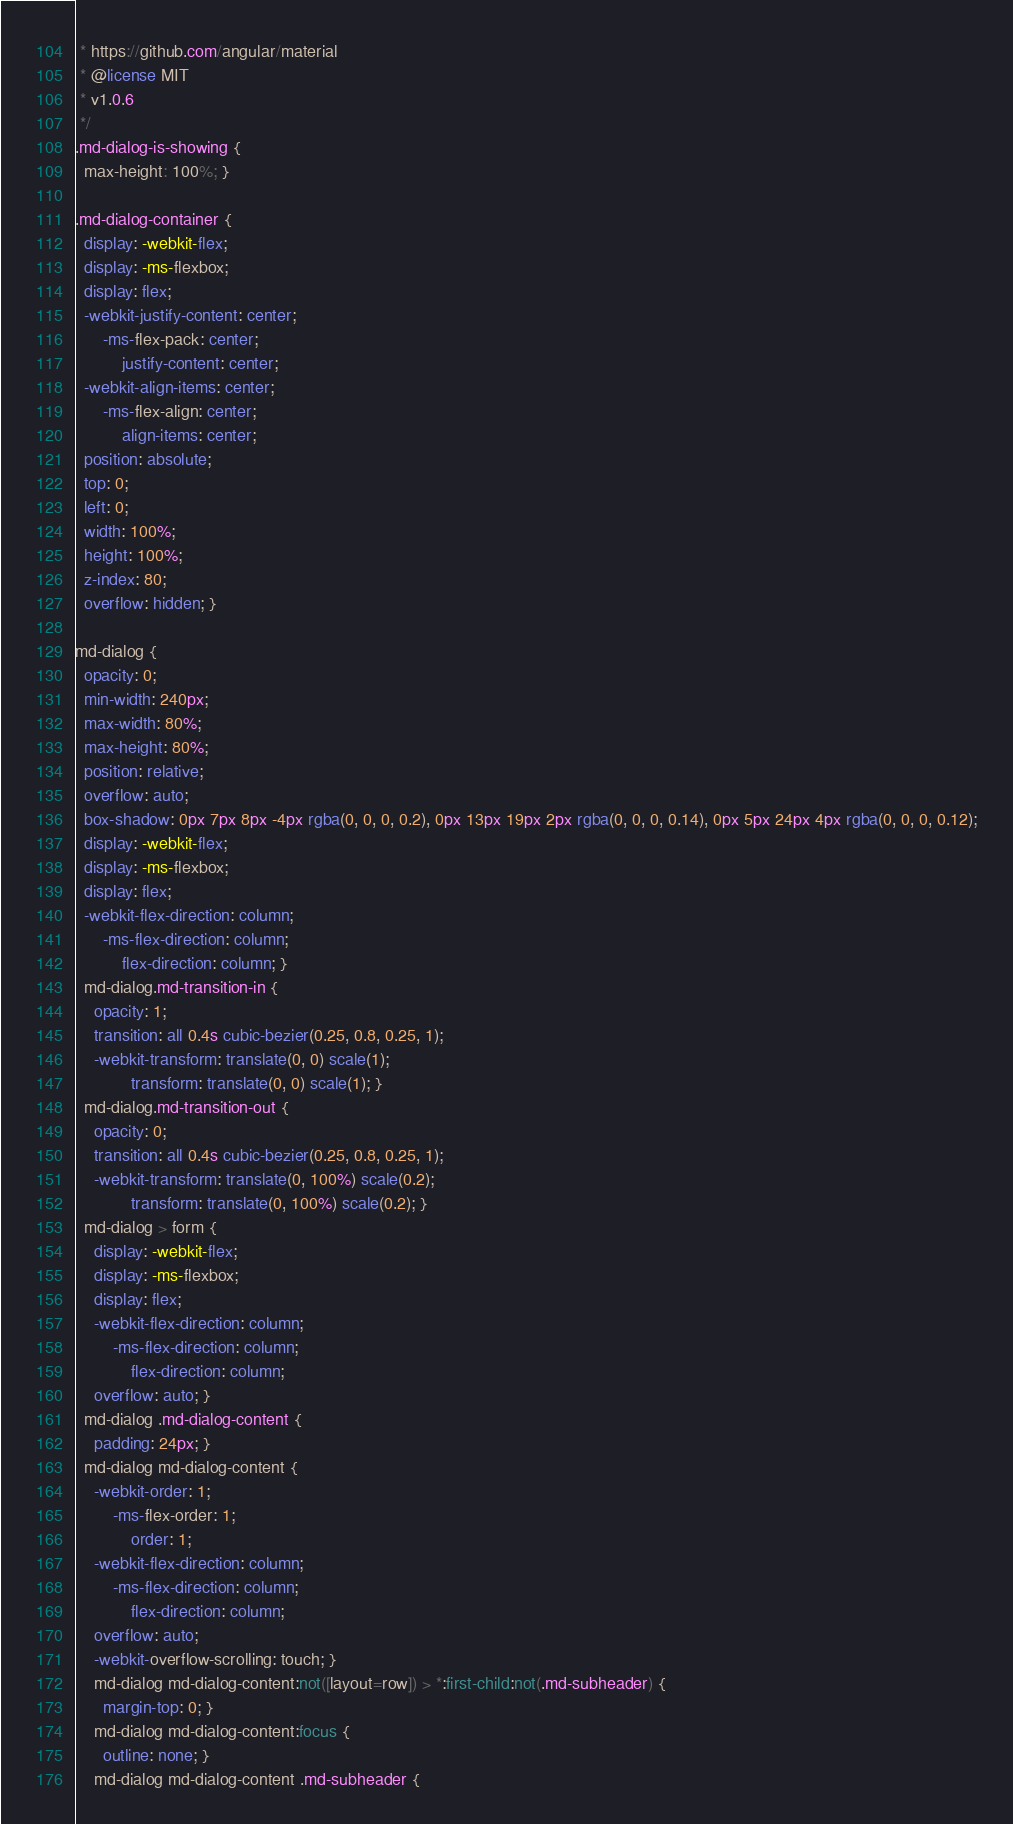Convert code to text. <code><loc_0><loc_0><loc_500><loc_500><_CSS_> * https://github.com/angular/material
 * @license MIT
 * v1.0.6
 */
.md-dialog-is-showing {
  max-height: 100%; }

.md-dialog-container {
  display: -webkit-flex;
  display: -ms-flexbox;
  display: flex;
  -webkit-justify-content: center;
      -ms-flex-pack: center;
          justify-content: center;
  -webkit-align-items: center;
      -ms-flex-align: center;
          align-items: center;
  position: absolute;
  top: 0;
  left: 0;
  width: 100%;
  height: 100%;
  z-index: 80;
  overflow: hidden; }

md-dialog {
  opacity: 0;
  min-width: 240px;
  max-width: 80%;
  max-height: 80%;
  position: relative;
  overflow: auto;
  box-shadow: 0px 7px 8px -4px rgba(0, 0, 0, 0.2), 0px 13px 19px 2px rgba(0, 0, 0, 0.14), 0px 5px 24px 4px rgba(0, 0, 0, 0.12);
  display: -webkit-flex;
  display: -ms-flexbox;
  display: flex;
  -webkit-flex-direction: column;
      -ms-flex-direction: column;
          flex-direction: column; }
  md-dialog.md-transition-in {
    opacity: 1;
    transition: all 0.4s cubic-bezier(0.25, 0.8, 0.25, 1);
    -webkit-transform: translate(0, 0) scale(1);
            transform: translate(0, 0) scale(1); }
  md-dialog.md-transition-out {
    opacity: 0;
    transition: all 0.4s cubic-bezier(0.25, 0.8, 0.25, 1);
    -webkit-transform: translate(0, 100%) scale(0.2);
            transform: translate(0, 100%) scale(0.2); }
  md-dialog > form {
    display: -webkit-flex;
    display: -ms-flexbox;
    display: flex;
    -webkit-flex-direction: column;
        -ms-flex-direction: column;
            flex-direction: column;
    overflow: auto; }
  md-dialog .md-dialog-content {
    padding: 24px; }
  md-dialog md-dialog-content {
    -webkit-order: 1;
        -ms-flex-order: 1;
            order: 1;
    -webkit-flex-direction: column;
        -ms-flex-direction: column;
            flex-direction: column;
    overflow: auto;
    -webkit-overflow-scrolling: touch; }
    md-dialog md-dialog-content:not([layout=row]) > *:first-child:not(.md-subheader) {
      margin-top: 0; }
    md-dialog md-dialog-content:focus {
      outline: none; }
    md-dialog md-dialog-content .md-subheader {</code> 